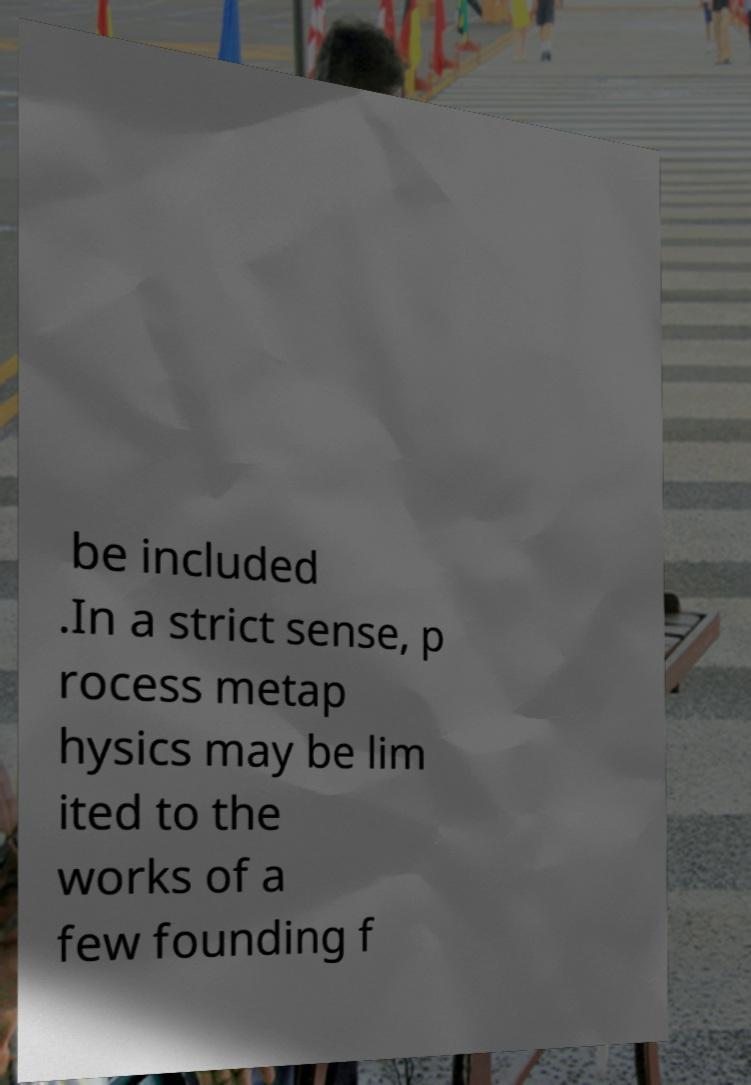There's text embedded in this image that I need extracted. Can you transcribe it verbatim? be included .In a strict sense, p rocess metap hysics may be lim ited to the works of a few founding f 